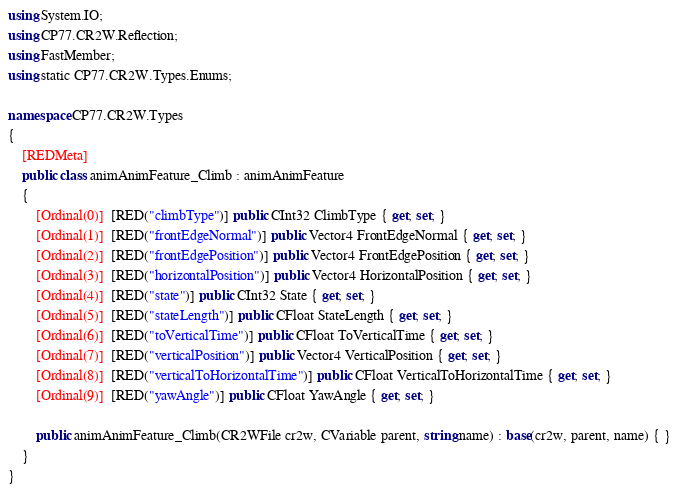Convert code to text. <code><loc_0><loc_0><loc_500><loc_500><_C#_>using System.IO;
using CP77.CR2W.Reflection;
using FastMember;
using static CP77.CR2W.Types.Enums;

namespace CP77.CR2W.Types
{
	[REDMeta]
	public class animAnimFeature_Climb : animAnimFeature
	{
		[Ordinal(0)]  [RED("climbType")] public CInt32 ClimbType { get; set; }
		[Ordinal(1)]  [RED("frontEdgeNormal")] public Vector4 FrontEdgeNormal { get; set; }
		[Ordinal(2)]  [RED("frontEdgePosition")] public Vector4 FrontEdgePosition { get; set; }
		[Ordinal(3)]  [RED("horizontalPosition")] public Vector4 HorizontalPosition { get; set; }
		[Ordinal(4)]  [RED("state")] public CInt32 State { get; set; }
		[Ordinal(5)]  [RED("stateLength")] public CFloat StateLength { get; set; }
		[Ordinal(6)]  [RED("toVerticalTime")] public CFloat ToVerticalTime { get; set; }
		[Ordinal(7)]  [RED("verticalPosition")] public Vector4 VerticalPosition { get; set; }
		[Ordinal(8)]  [RED("verticalToHorizontalTime")] public CFloat VerticalToHorizontalTime { get; set; }
		[Ordinal(9)]  [RED("yawAngle")] public CFloat YawAngle { get; set; }

		public animAnimFeature_Climb(CR2WFile cr2w, CVariable parent, string name) : base(cr2w, parent, name) { }
	}
}
</code> 